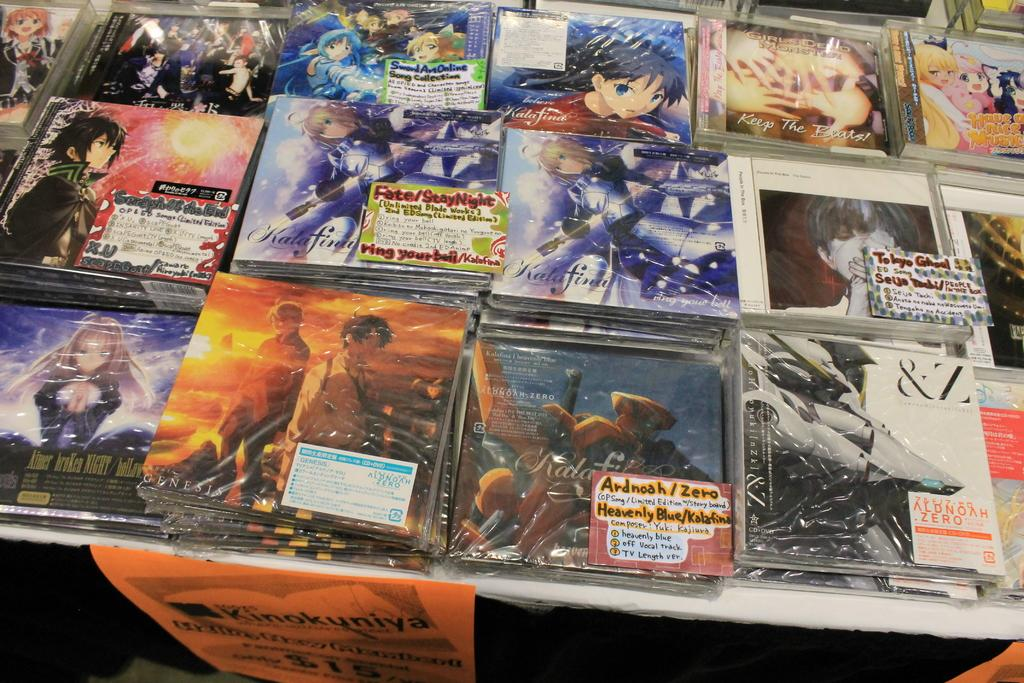<image>
Present a compact description of the photo's key features. A cover is labeled Heavenly Blue and is surrounded by many others. 